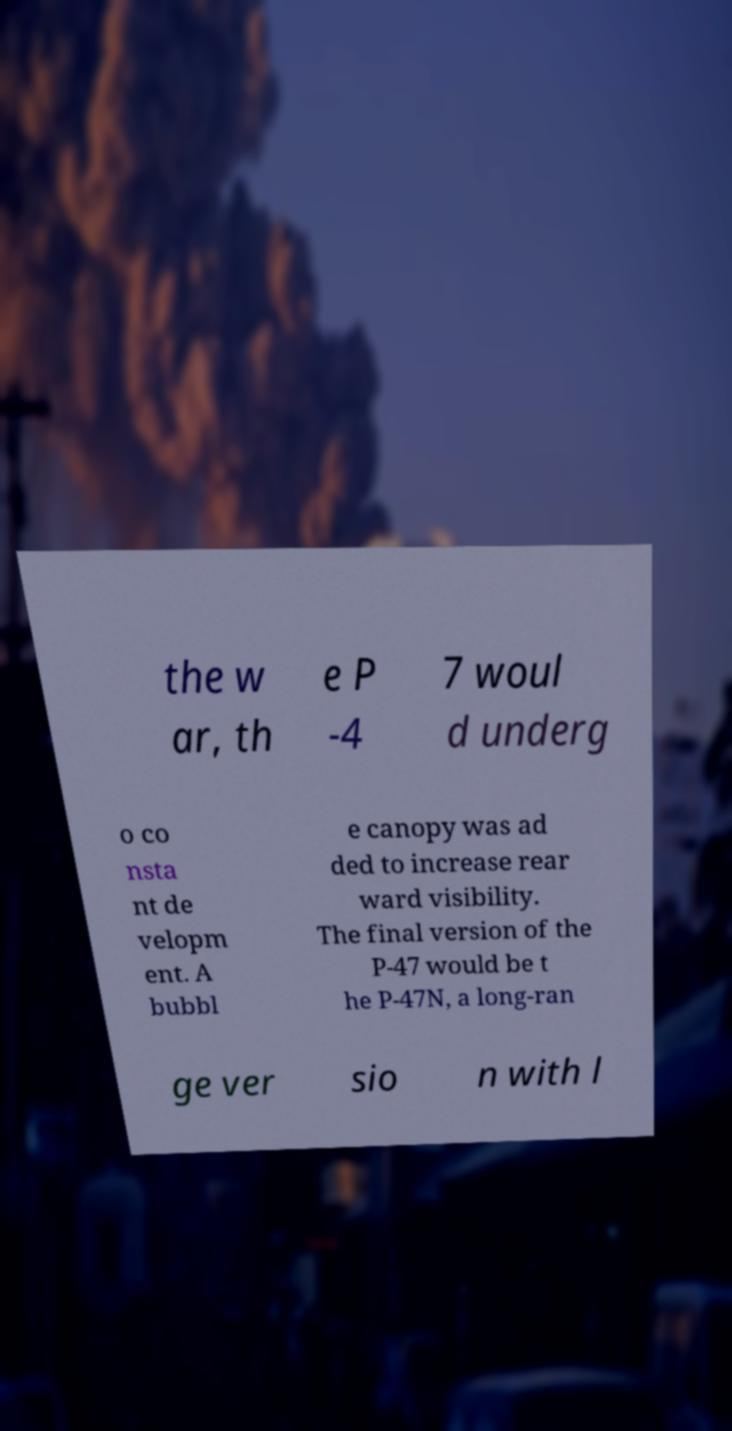I need the written content from this picture converted into text. Can you do that? the w ar, th e P -4 7 woul d underg o co nsta nt de velopm ent. A bubbl e canopy was ad ded to increase rear ward visibility. The final version of the P-47 would be t he P-47N, a long-ran ge ver sio n with l 